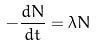<formula> <loc_0><loc_0><loc_500><loc_500>- \frac { d N } { d t } = \lambda N</formula> 